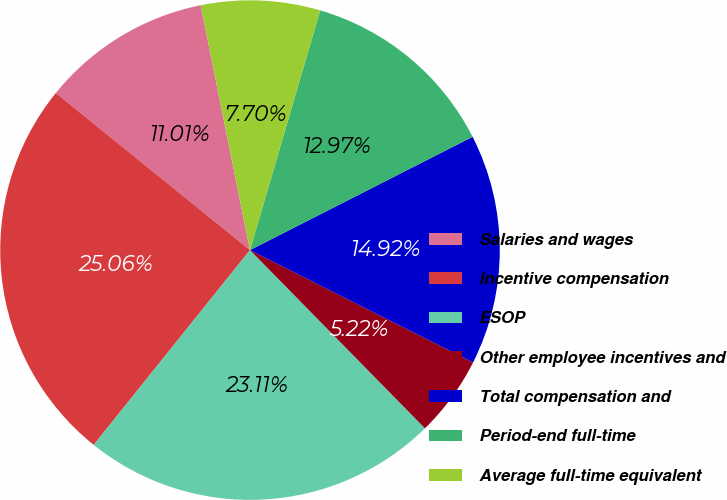<chart> <loc_0><loc_0><loc_500><loc_500><pie_chart><fcel>Salaries and wages<fcel>Incentive compensation<fcel>ESOP<fcel>Other employee incentives and<fcel>Total compensation and<fcel>Period-end full-time<fcel>Average full-time equivalent<nl><fcel>11.01%<fcel>25.06%<fcel>23.11%<fcel>5.22%<fcel>14.92%<fcel>12.97%<fcel>7.7%<nl></chart> 